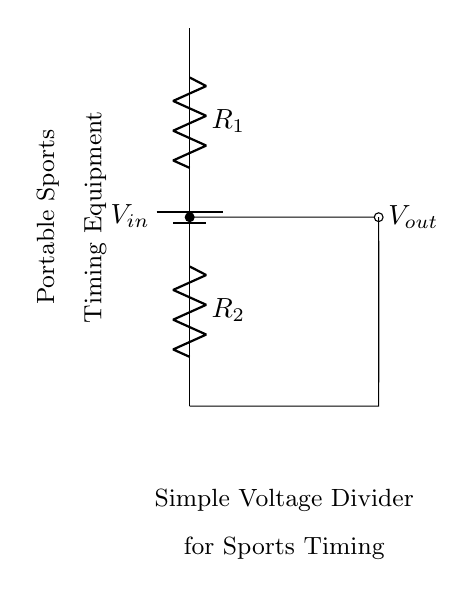What is the input voltage in the circuit? The input voltage is denoted as V_in in the circuit diagram. This represents the voltage supplied to the voltage divider circuit.
Answer: V_in What are the resistors labeled in the circuit? The resistors in the circuit are labeled R_1 and R_2. These are the two resistive components used in the voltage divider to split the input voltage.
Answer: R_1, R_2 Where is the output voltage taken from? The output voltage, V_out, is taken from the node between R_1 and R_2, indicated by the connection to the right of R_1. This is where the reduced voltage is measured for the timing equipment.
Answer: Between R_1 and R_2 How many resistors are in this voltage divider? There are two resistors used in this circuit, which are crucial for dividing the input voltage to obtain a lower output voltage for the portable sports timing equipment.
Answer: Two What is the purpose of this voltage divider? The purpose of this voltage divider is to provide a lower output voltage suitable for powering the portable sports timing equipment from a higher voltage input.
Answer: To power timing equipment How does changing the resistance values affect the output voltage? Changing R_1 and R_2 will alter the voltage division ratio, thereby affecting the output voltage. The output voltage can be calculated using the formula V_out = (R_2 / (R_1 + R_2)) × V_in. Thus, increasing R_2 or decreasing R_1 will increase V_out, while the opposite will decrease it.
Answer: It affects V_out What type of circuit is depicted in the diagram? The circuit is a voltage divider, specifically designed to divide the voltage for supplying appropriate levels to electronic components, like the timing equipment shown.
Answer: Voltage Divider 